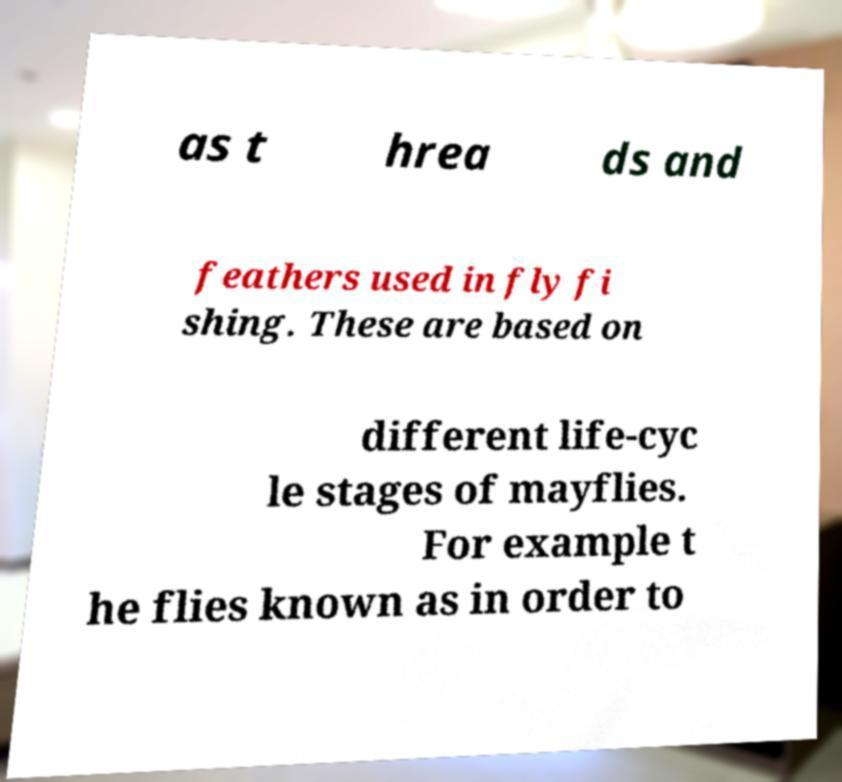What messages or text are displayed in this image? I need them in a readable, typed format. as t hrea ds and feathers used in fly fi shing. These are based on different life-cyc le stages of mayflies. For example t he flies known as in order to 